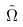Convert formula to latex. <formula><loc_0><loc_0><loc_500><loc_500>\tilde { \Omega }</formula> 